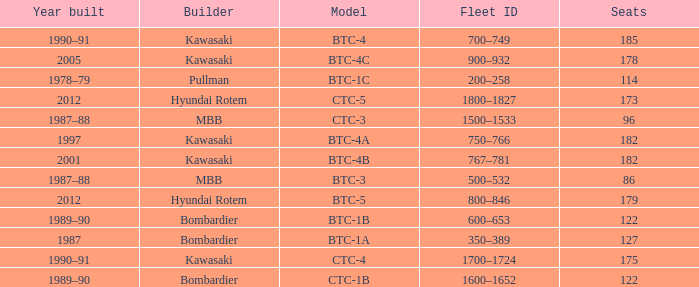In what year was the ctc-3 model built? 1987–88. 